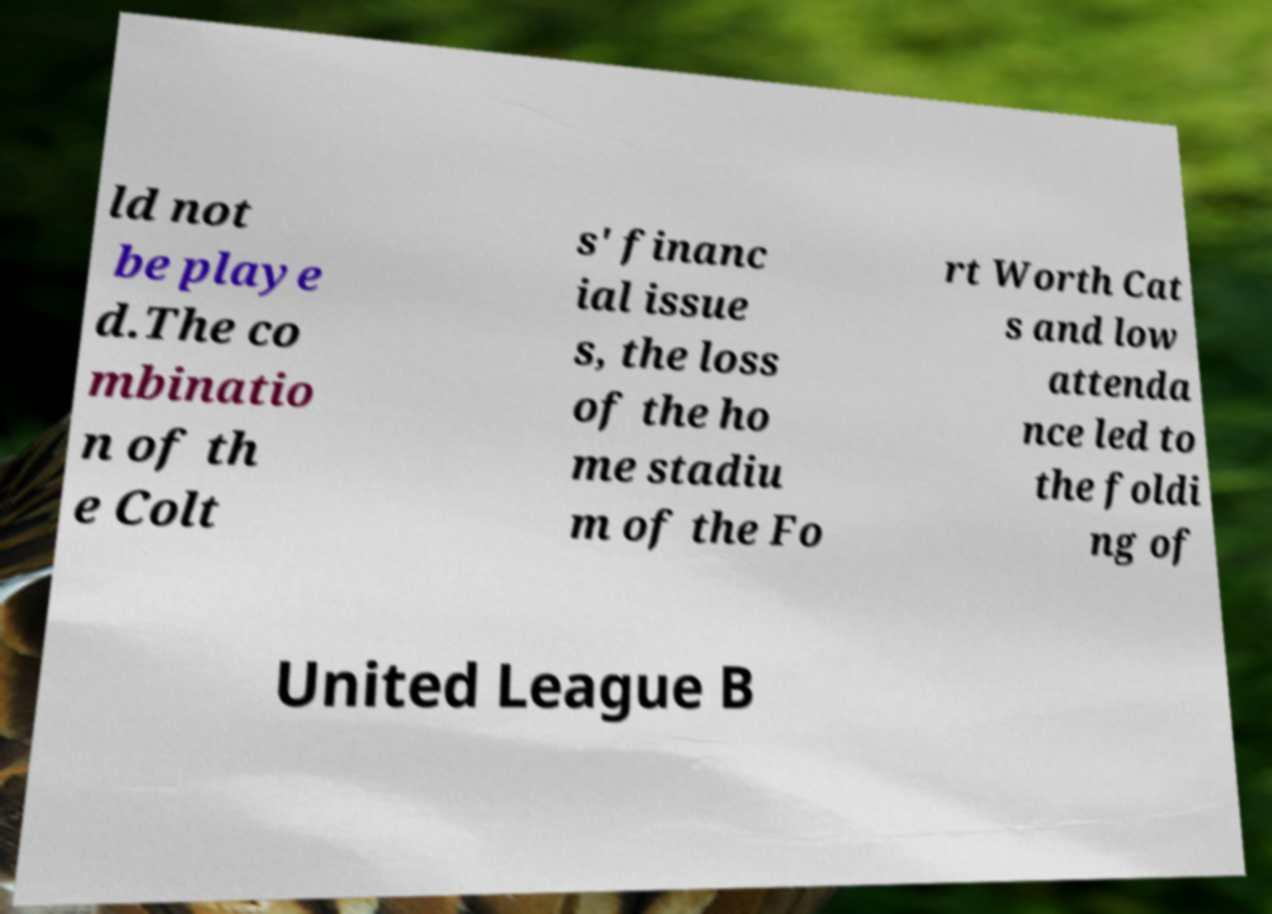For documentation purposes, I need the text within this image transcribed. Could you provide that? ld not be playe d.The co mbinatio n of th e Colt s' financ ial issue s, the loss of the ho me stadiu m of the Fo rt Worth Cat s and low attenda nce led to the foldi ng of United League B 